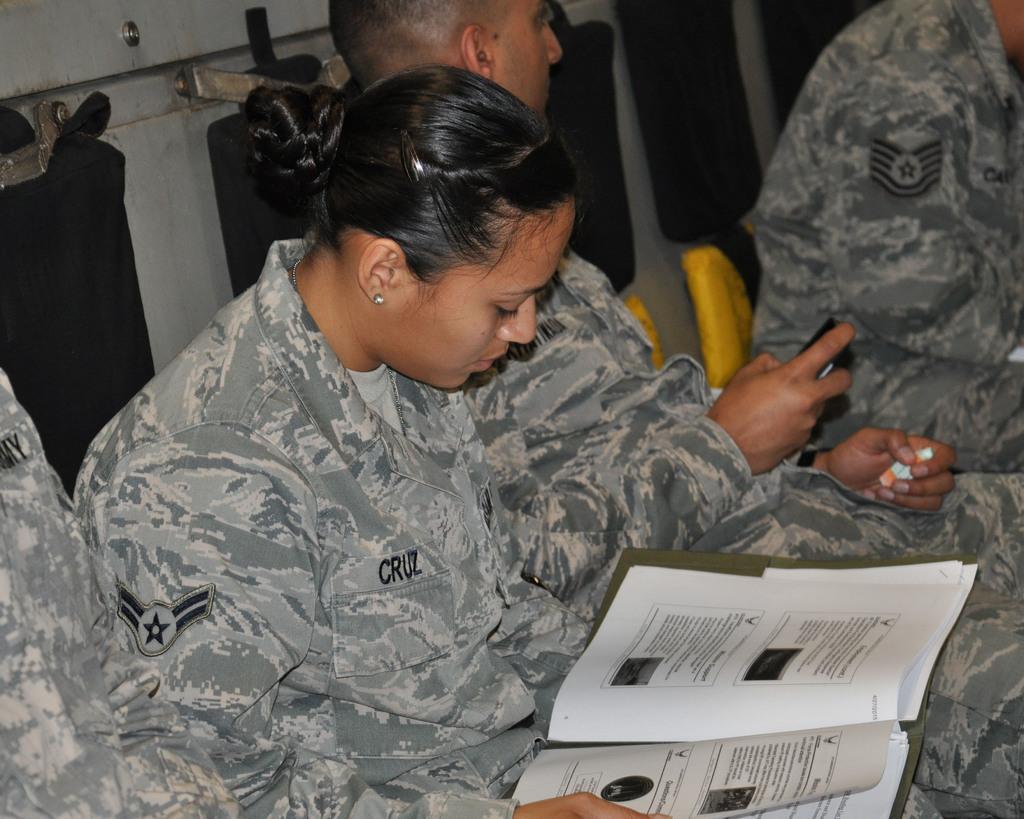Can you describe this image briefly? In this image there are persons sitting. In the front there is a woman holding a file in her hand. In the background there are objects which are black in colour and yellow in colour. 